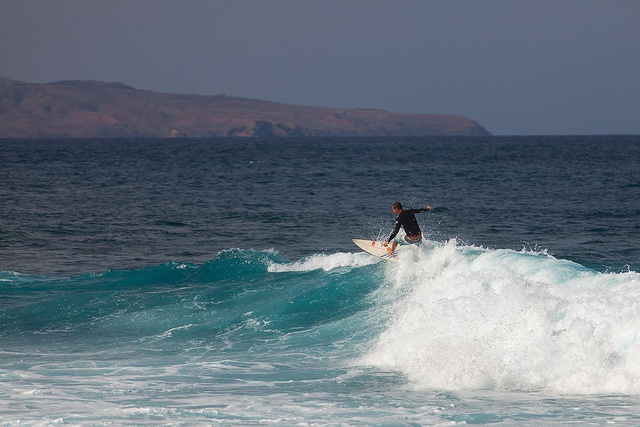Describe the objects in this image and their specific colors. I can see people in gray, black, darkgray, and maroon tones and surfboard in gray, tan, lightgray, and darkgray tones in this image. 